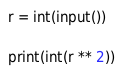Convert code to text. <code><loc_0><loc_0><loc_500><loc_500><_Python_>r = int(input())

print(int(r ** 2))</code> 